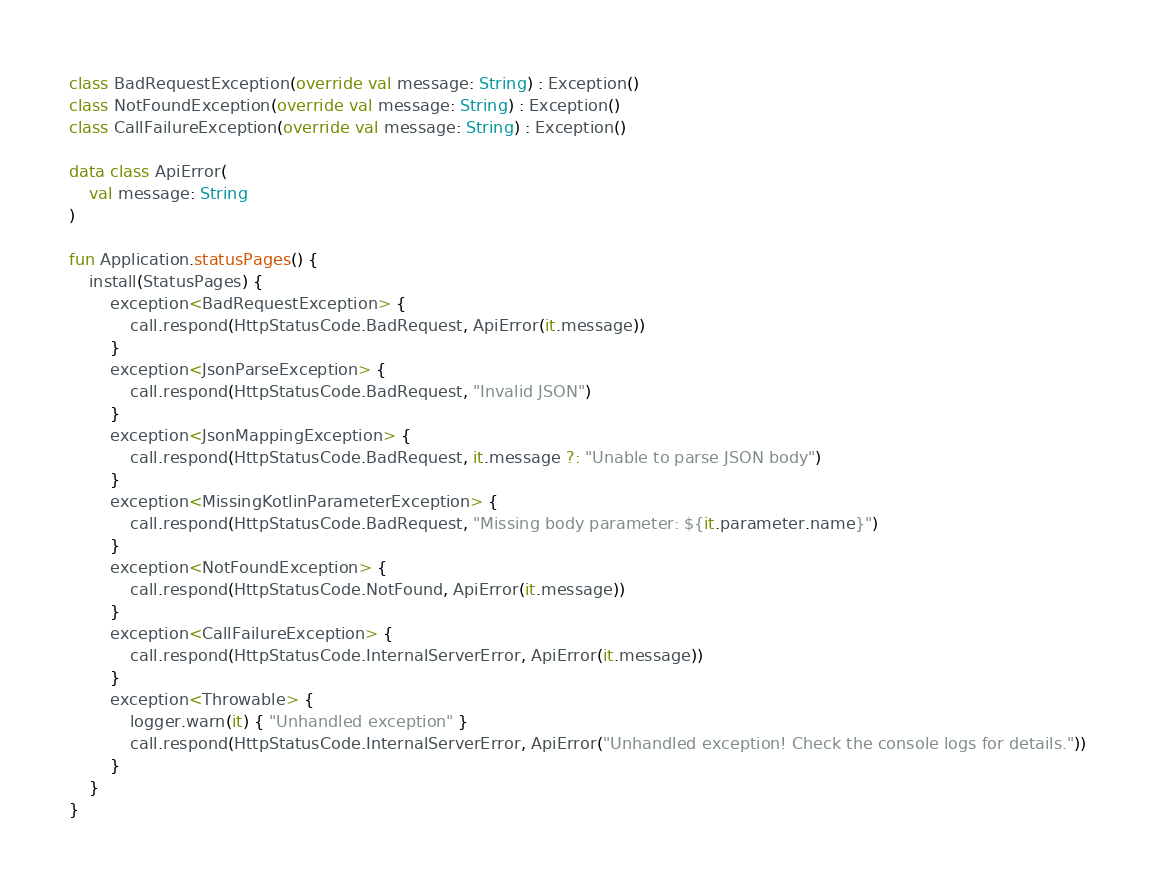Convert code to text. <code><loc_0><loc_0><loc_500><loc_500><_Kotlin_>class BadRequestException(override val message: String) : Exception()
class NotFoundException(override val message: String) : Exception()
class CallFailureException(override val message: String) : Exception()

data class ApiError(
    val message: String
)

fun Application.statusPages() {
    install(StatusPages) {
        exception<BadRequestException> {
            call.respond(HttpStatusCode.BadRequest, ApiError(it.message))
        }
        exception<JsonParseException> {
            call.respond(HttpStatusCode.BadRequest, "Invalid JSON")
        }
        exception<JsonMappingException> {
            call.respond(HttpStatusCode.BadRequest, it.message ?: "Unable to parse JSON body")
        }
        exception<MissingKotlinParameterException> {
            call.respond(HttpStatusCode.BadRequest, "Missing body parameter: ${it.parameter.name}")
        }
        exception<NotFoundException> {
            call.respond(HttpStatusCode.NotFound, ApiError(it.message))
        }
        exception<CallFailureException> {
            call.respond(HttpStatusCode.InternalServerError, ApiError(it.message))
        }
        exception<Throwable> {
            logger.warn(it) { "Unhandled exception" }
            call.respond(HttpStatusCode.InternalServerError, ApiError("Unhandled exception! Check the console logs for details."))
        }
    }
}

</code> 